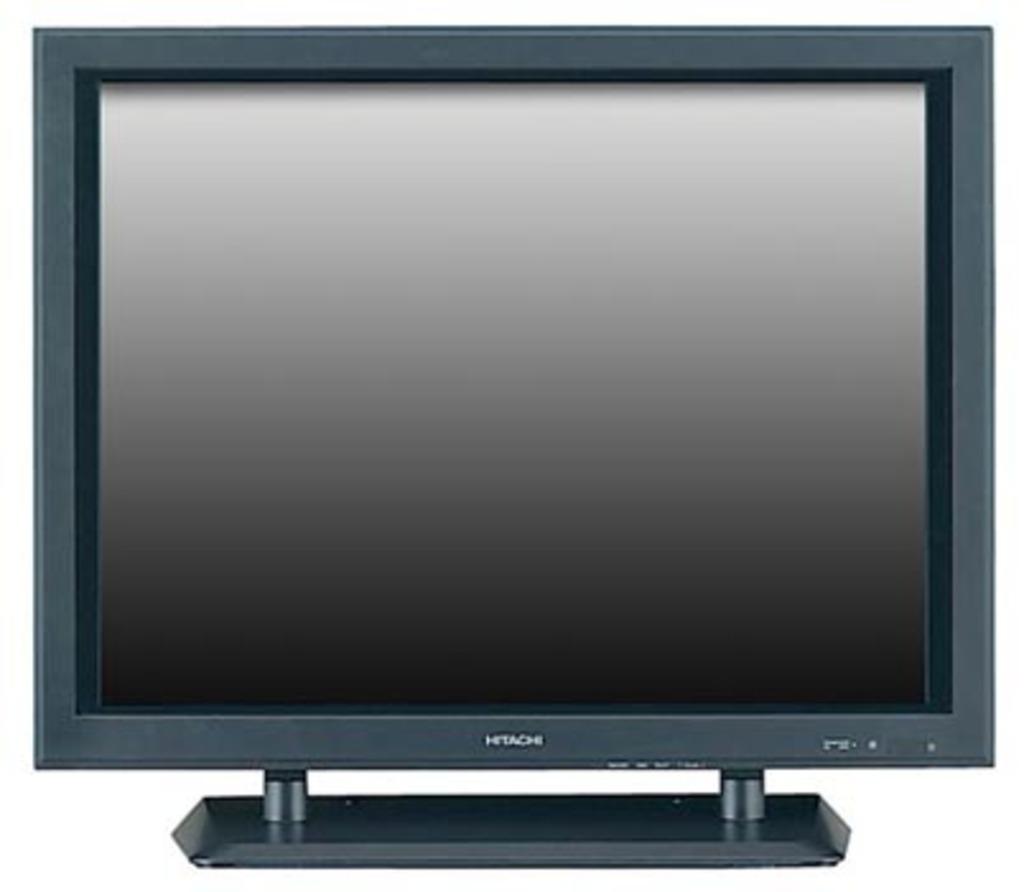What brand of monitor is this?
Provide a short and direct response. Hitachi. 